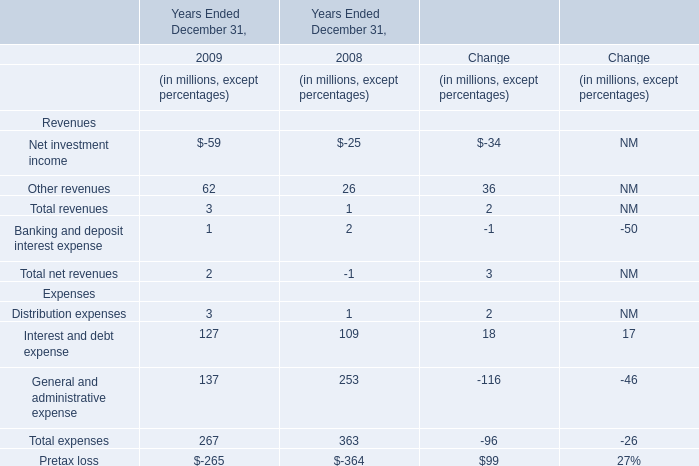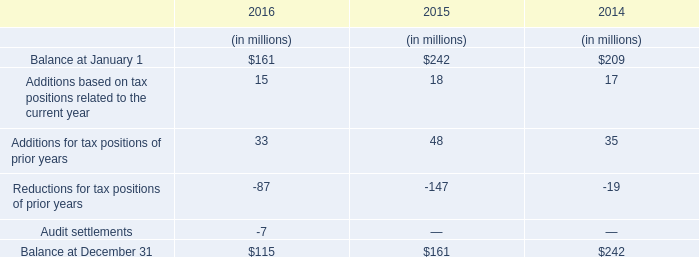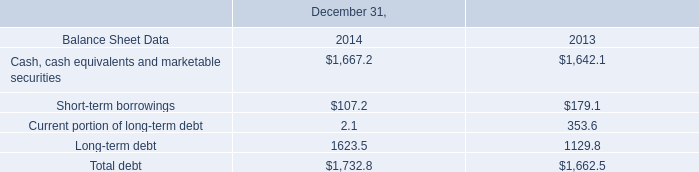Which year the Interest and debt expense is the highest? 
Answer: 2009. 